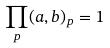Convert formula to latex. <formula><loc_0><loc_0><loc_500><loc_500>\prod _ { p } ( a , b ) _ { p } = 1</formula> 